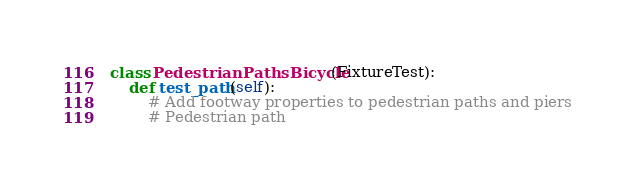Convert code to text. <code><loc_0><loc_0><loc_500><loc_500><_Python_>

class PedestrianPathsBicycle(FixtureTest):
    def test_path(self):
        # Add footway properties to pedestrian paths and piers
        # Pedestrian path</code> 